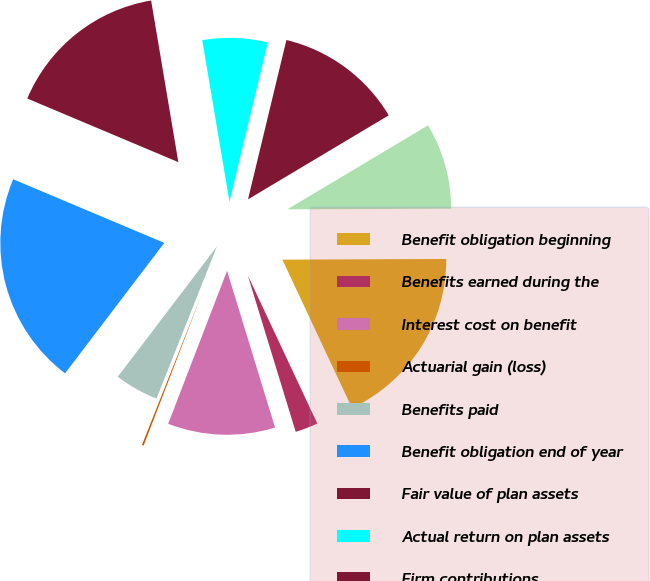Convert chart. <chart><loc_0><loc_0><loc_500><loc_500><pie_chart><fcel>Benefit obligation beginning<fcel>Benefits earned during the<fcel>Interest cost on benefit<fcel>Actuarial gain (loss)<fcel>Benefits paid<fcel>Benefit obligation end of year<fcel>Fair value of plan assets<fcel>Actual return on plan assets<fcel>Firm contributions<fcel>Funded (unfunded) status<nl><fcel>18.09%<fcel>2.25%<fcel>10.58%<fcel>0.17%<fcel>4.33%<fcel>21.0%<fcel>16.0%<fcel>6.42%<fcel>12.67%<fcel>8.5%<nl></chart> 